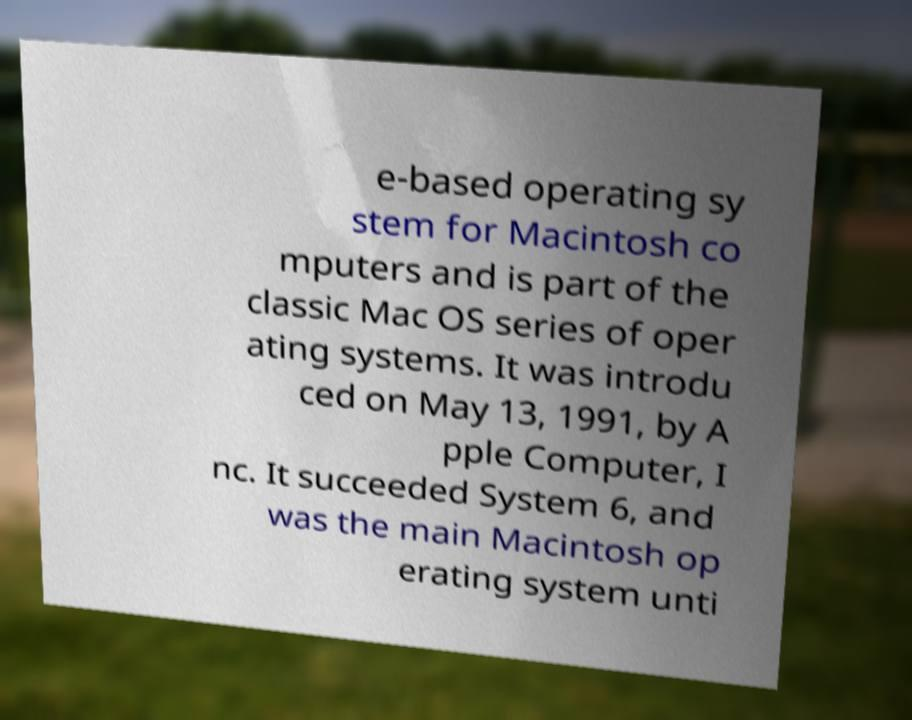Could you extract and type out the text from this image? e-based operating sy stem for Macintosh co mputers and is part of the classic Mac OS series of oper ating systems. It was introdu ced on May 13, 1991, by A pple Computer, I nc. It succeeded System 6, and was the main Macintosh op erating system unti 